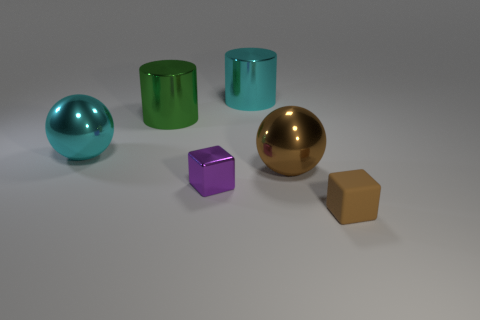Do the green metal cylinder that is behind the brown metal sphere and the cyan metallic thing in front of the large cyan metal cylinder have the same size?
Your answer should be very brief. Yes. Is there a large object that has the same material as the cyan cylinder?
Offer a terse response. Yes. How many things are large cyan things behind the big green metal cylinder or spheres?
Offer a very short reply. 3. Is the material of the sphere left of the small purple metallic block the same as the purple thing?
Offer a terse response. Yes. Is the purple metallic thing the same shape as the brown matte thing?
Ensure brevity in your answer.  Yes. What number of tiny shiny cubes are in front of the large shiny sphere that is to the right of the big cyan cylinder?
Provide a succinct answer. 1. There is another thing that is the same shape as the big green thing; what material is it?
Provide a succinct answer. Metal. There is a large metallic object on the right side of the cyan metallic cylinder; does it have the same color as the matte block?
Keep it short and to the point. Yes. Is the material of the green cylinder the same as the small block on the right side of the big brown thing?
Make the answer very short. No. There is a small thing right of the tiny metal block; what shape is it?
Provide a succinct answer. Cube. 